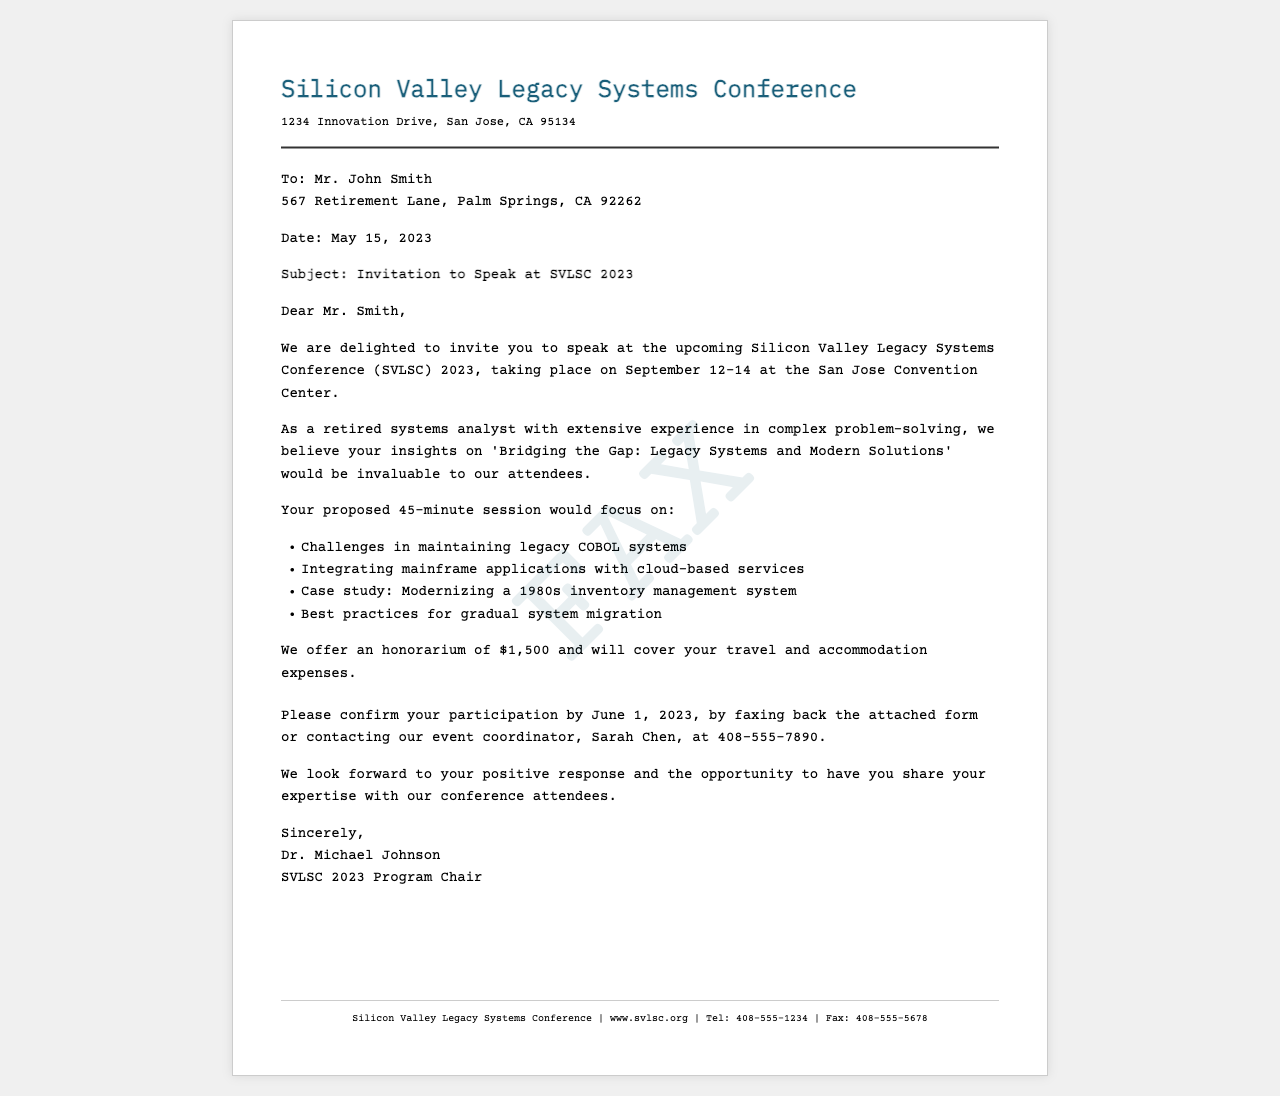What is the date of the conference? The document states the conference date is September 12-14, 2023.
Answer: September 12-14 Who is the recipient of the fax? The recipient of the fax is mentioned at the top of the document.
Answer: Mr. John Smith What is the proposed duration of the session? The document indicates that the proposed session would last for 45 minutes.
Answer: 45 minutes What is the honorarium offered for the session? The honorarium stated in the document is $1,500.
Answer: $1,500 Who should be contacted for confirmation? The document specifies that the event coordinator, Sarah Chen, should be contacted.
Answer: Sarah Chen What is the main topic of the proposed session? The main topic of the proposed session is mentioned in the invitation.
Answer: Bridging the Gap: Legacy Systems and Modern Solutions What is the deadline for confirming participation? The document clearly states the deadline to confirm participation is by June 1, 2023.
Answer: June 1, 2023 What type of document is this? This document is identified as an invitation to speak at a conference.
Answer: Invitation to Speak 